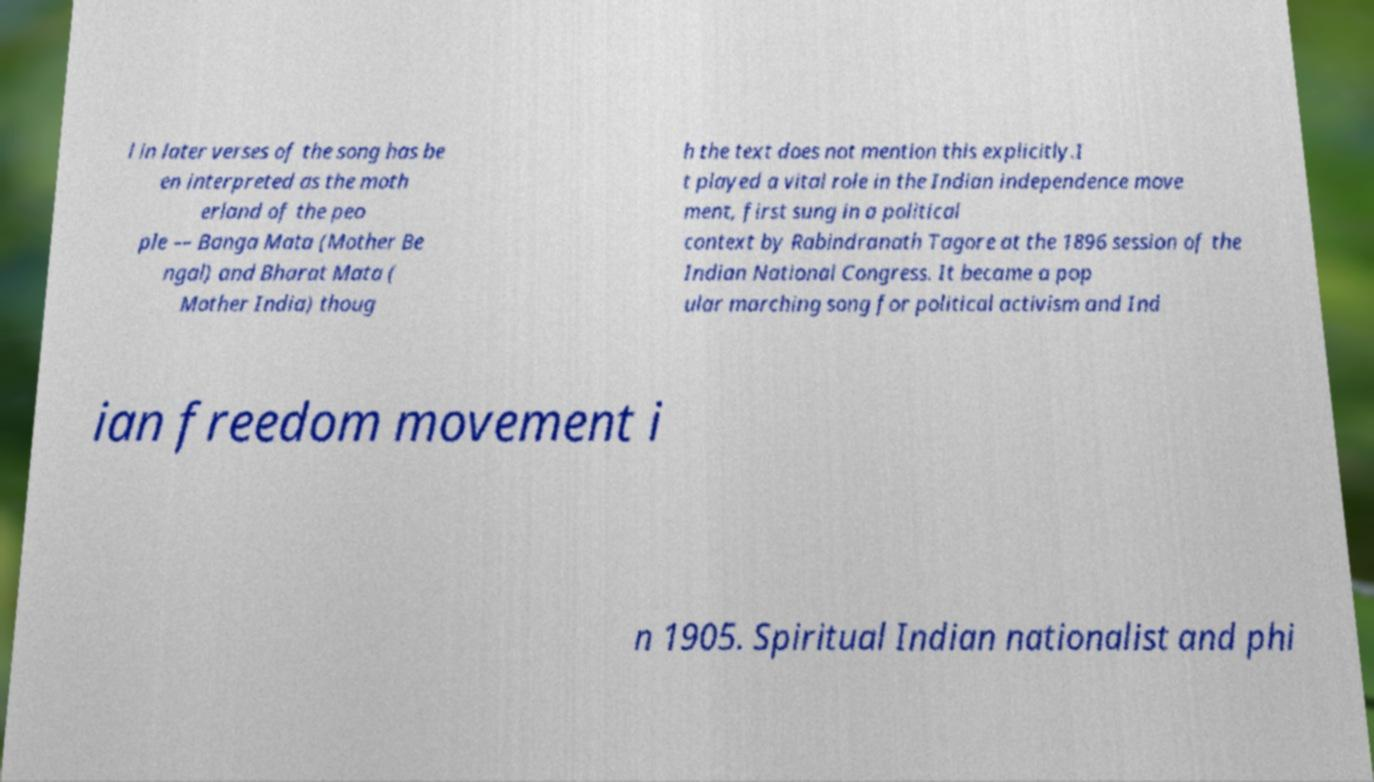Can you read and provide the text displayed in the image?This photo seems to have some interesting text. Can you extract and type it out for me? l in later verses of the song has be en interpreted as the moth erland of the peo ple –– Banga Mata (Mother Be ngal) and Bharat Mata ( Mother India) thoug h the text does not mention this explicitly.I t played a vital role in the Indian independence move ment, first sung in a political context by Rabindranath Tagore at the 1896 session of the Indian National Congress. It became a pop ular marching song for political activism and Ind ian freedom movement i n 1905. Spiritual Indian nationalist and phi 